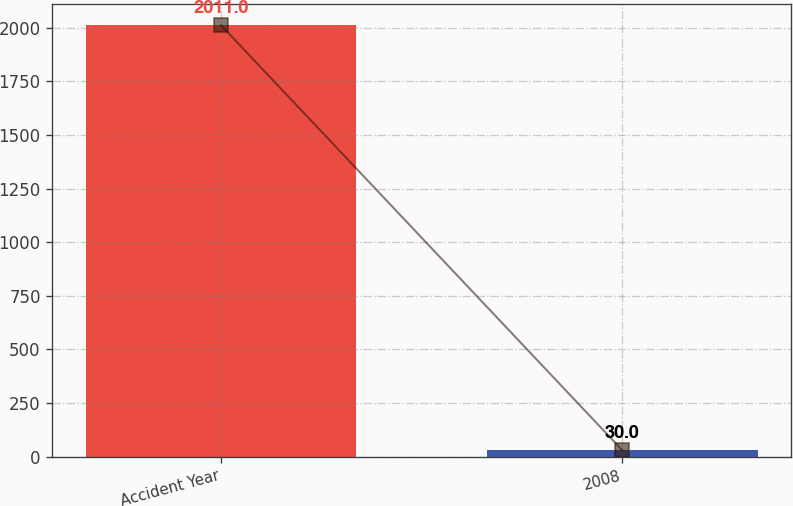Convert chart to OTSL. <chart><loc_0><loc_0><loc_500><loc_500><bar_chart><fcel>Accident Year<fcel>2008<nl><fcel>2011<fcel>30<nl></chart> 